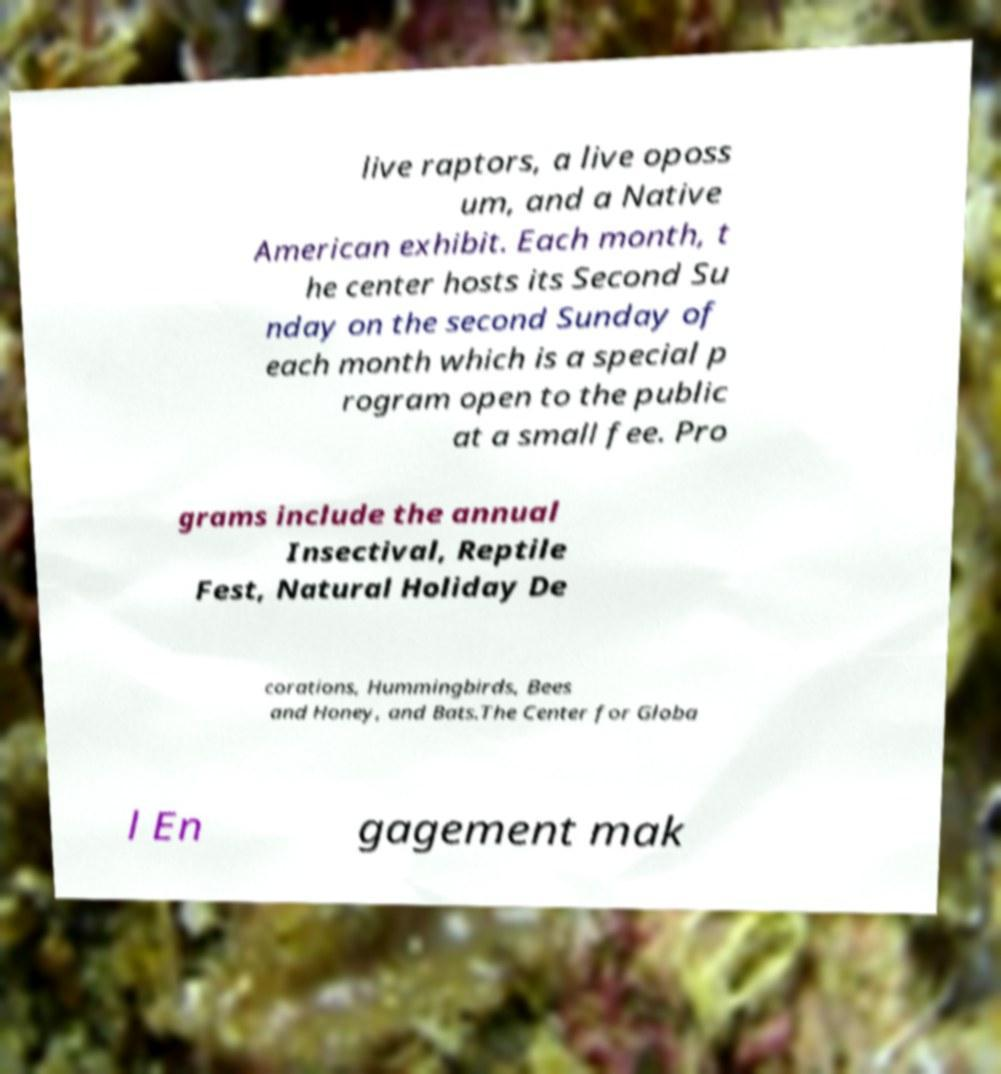What messages or text are displayed in this image? I need them in a readable, typed format. live raptors, a live oposs um, and a Native American exhibit. Each month, t he center hosts its Second Su nday on the second Sunday of each month which is a special p rogram open to the public at a small fee. Pro grams include the annual Insectival, Reptile Fest, Natural Holiday De corations, Hummingbirds, Bees and Honey, and Bats.The Center for Globa l En gagement mak 